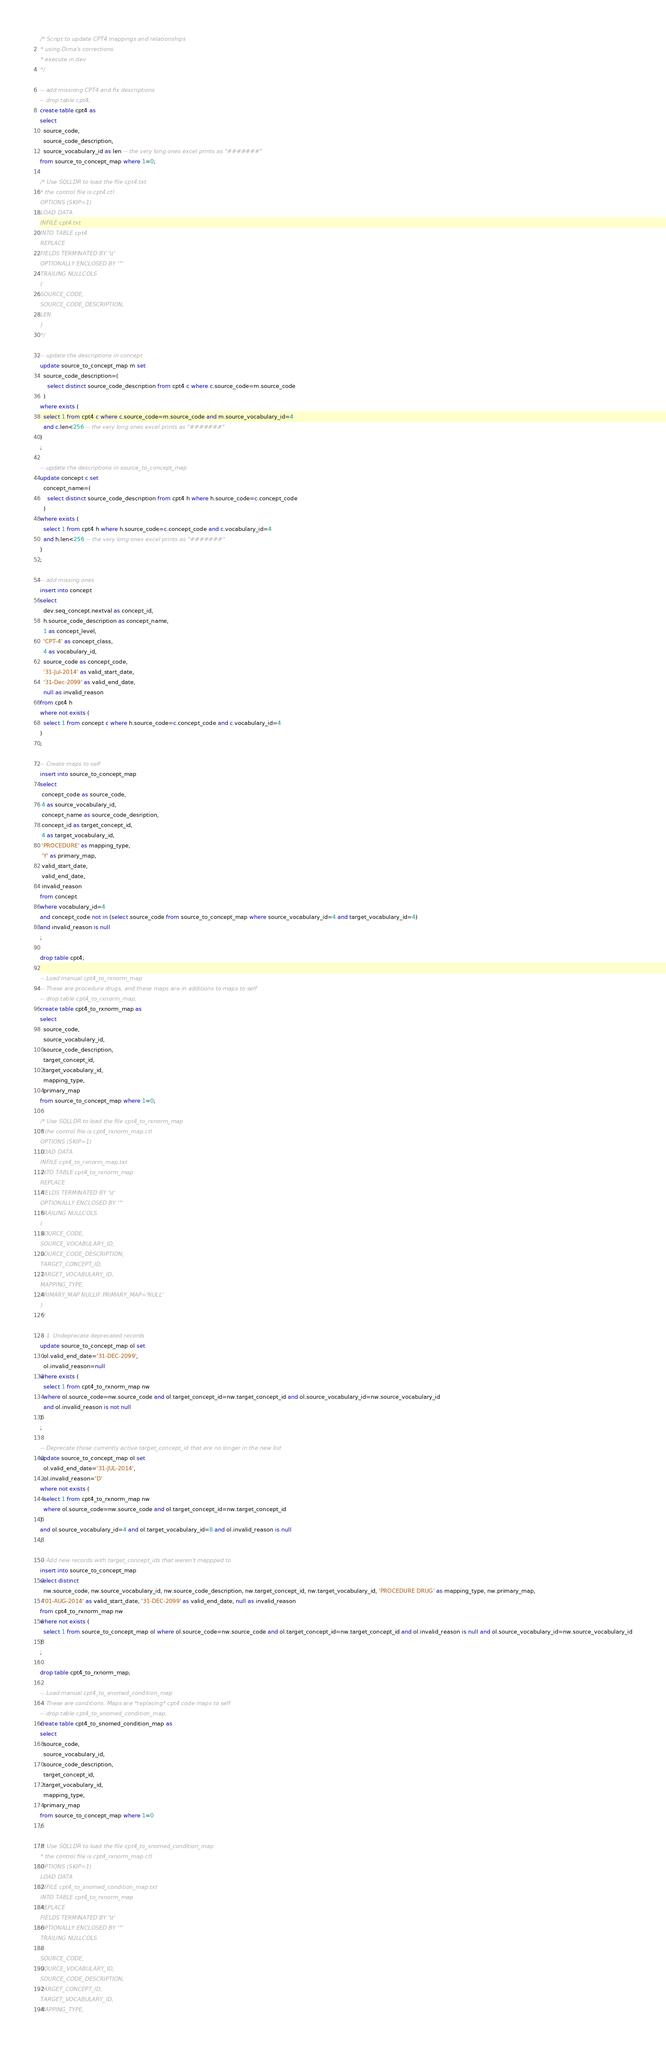<code> <loc_0><loc_0><loc_500><loc_500><_SQL_>/* Script to update CPT4 mappings and relationships
* using Dima's corrections
* execute in dev
*/

-- add missiong CPT4 and fix descriptions
-- drop table cpt4;
create table cpt4 as
select 
  source_code,  
  source_code_description,
  source_vocabulary_id as len -- the very long ones excel prints as "#######"
from source_to_concept_map where 1=0;

/* Use SQLLDR to load the file cpt4.txt
* the control file is cpt4.ctl
OPTIONS (SKIP=1)
LOAD DATA
INFILE cpt4.txt
INTO TABLE cpt4
REPLACE
FIELDS TERMINATED BY '\t'
OPTIONALLY ENCLOSED BY '"'
TRAILING NULLCOLS
(
SOURCE_CODE,  
SOURCE_CODE_DESCRIPTION,
LEN
)
*/

-- update the descriptions in concept
update source_to_concept_map m set
  source_code_description=(
    select distinct source_code_description from cpt4 c where c.source_code=m.source_code
  )
where exists (
  select 1 from cpt4 c where c.source_code=m.source_code and m.source_vocabulary_id=4
  and c.len<256 -- the very long ones excel prints as "#######"
)
;

-- update the descriptions in source_to_concept_map
update concept c set
  concept_name=(
    select distinct source_code_description from cpt4 h where h.source_code=c.concept_code
  )
where exists (
  select 1 from cpt4 h where h.source_code=c.concept_code and c.vocabulary_id=4
  and h.len<256 -- the very long ones excel prints as "#######"
)
;

-- add missing ones 
insert into concept
select 
  dev.seq_concept.nextval as concept_id,
  h.source_code_description as concept_name,
  1 as concept_level,
  'CPT-4' as concept_class,
  4 as vocabulary_id,
  source_code as concept_code,
  '31-Jul-2014' as valid_start_date,
  '31-Dec-2099' as valid_end_date,
  null as invalid_reason
from cpt4 h 
where not exists (
  select 1 from concept c where h.source_code=c.concept_code and c.vocabulary_id=4
)
;

-- Create maps to self
insert into source_to_concept_map 
select 
 concept_code as source_code,
 4 as source_vocabulary_id,
 concept_name as source_code_desription,
 concept_id as target_concept_id,
 4 as target_vocabulary_id,
 'PROCEDURE' as mapping_type,
 'Y' as primary_map,
 valid_start_date,
 valid_end_date,
 invalid_reason
from concept 
where vocabulary_id=4 
and concept_code not in (select source_code from source_to_concept_map where source_vocabulary_id=4 and target_vocabulary_id=4)
and invalid_reason is null
;

drop table cpt4;

-- Load manual cpt4_to_rxnorm_map
-- These are procedure drugs, and these maps are in additions to maps to self
-- drop table cpt4_to_rxnorm_map;
create table cpt4_to_rxnorm_map as
select 
  source_code,  
  source_vocabulary_id,
  source_code_description,
  target_concept_id,
  target_vocabulary_id,
  mapping_type,
  primary_map
from source_to_concept_map where 1=0;

/* Use SQLLDR to load the file cpt4_to_rxnorm_map
* the control file is cpt4_rxnorm_map.ctl
OPTIONS (SKIP=1)
LOAD DATA
INFILE cpt4_to_rxnorm_map.txt
INTO TABLE cpt4_to_rxnorm_map
REPLACE
FIELDS TERMINATED BY '\t'
OPTIONALLY ENCLOSED BY '"'
TRAILING NULLCOLS
(
SOURCE_CODE,  
SOURCE_VOCABULARY_ID,
SOURCE_CODE_DESCRIPTION,
TARGET_CONCEPT_ID,
TARGET_VOCABULARY_ID,
MAPPING_TYPE,
PRIMARY_MAP NULLIF PRIMARY_MAP='NULL'
)
*/

-- 1. Undeprecate deprecated records
update source_to_concept_map ol set
  ol.valid_end_date='31-DEC-2099',
  ol.invalid_reason=null
where exists (
  select 1 from cpt4_to_rxnorm_map nw 
  where ol.source_code=nw.source_code and ol.target_concept_id=nw.target_concept_id and ol.source_vocabulary_id=nw.source_vocabulary_id
  and ol.invalid_reason is not null
)
;

-- Deprecate those currently active target_concept_id that are no longer in the new list
update source_to_concept_map ol set
  ol.valid_end_date='31-JUL-2014',
  ol.invalid_reason='D'
where not exists (
  select 1 from cpt4_to_rxnorm_map nw 
  where ol.source_code=nw.source_code and ol.target_concept_id=nw.target_concept_id
)
and ol.source_vocabulary_id=4 and ol.target_vocabulary_id=8 and ol.invalid_reason is null
;

-- Add new records with target_concept_ids that weren't mappped to
insert into source_to_concept_map
select distinct 
  nw.source_code, nw.source_vocabulary_id, nw.source_code_description, nw.target_concept_id, nw.target_vocabulary_id, 'PROCEDURE DRUG' as mapping_type, nw.primary_map, 
  '01-AUG-2014' as valid_start_date, '31-DEC-2099' as valid_end_date, null as invalid_reason
from cpt4_to_rxnorm_map nw
where not exists (
  select 1 from source_to_concept_map ol where ol.source_code=nw.source_code and ol.target_concept_id=nw.target_concept_id and ol.invalid_reason is null and ol.source_vocabulary_id=nw.source_vocabulary_id
)
;

drop table cpt4_to_rxnorm_map;

-- Load manual cpt4_to_snomed_condition_map
-- These are conditions. Maps are *replacing* cpt4 code maps to self
-- drop table cpt4_to_snomed_condition_map;
create table cpt4_to_snomed_condition_map as
select 
  source_code,  
  source_vocabulary_id,
  source_code_description,
  target_concept_id,
  target_vocabulary_id,
  mapping_type,
  primary_map
from source_to_concept_map where 1=0
;

/* Use SQLLDR to load the file cpt4_to_snomed_condition_map
* the control file is cpt4_rxnorm_map.ctl
OPTIONS (SKIP=1)
LOAD DATA
INFILE cpt4_to_snomed_condition_map.txt
INTO TABLE cpt4_to_rxnorm_map
REPLACE
FIELDS TERMINATED BY '\t'
OPTIONALLY ENCLOSED BY '"'
TRAILING NULLCOLS
(
SOURCE_CODE,  
SOURCE_VOCABULARY_ID,
SOURCE_CODE_DESCRIPTION,
TARGET_CONCEPT_ID,
TARGET_VOCABULARY_ID,
MAPPING_TYPE,</code> 